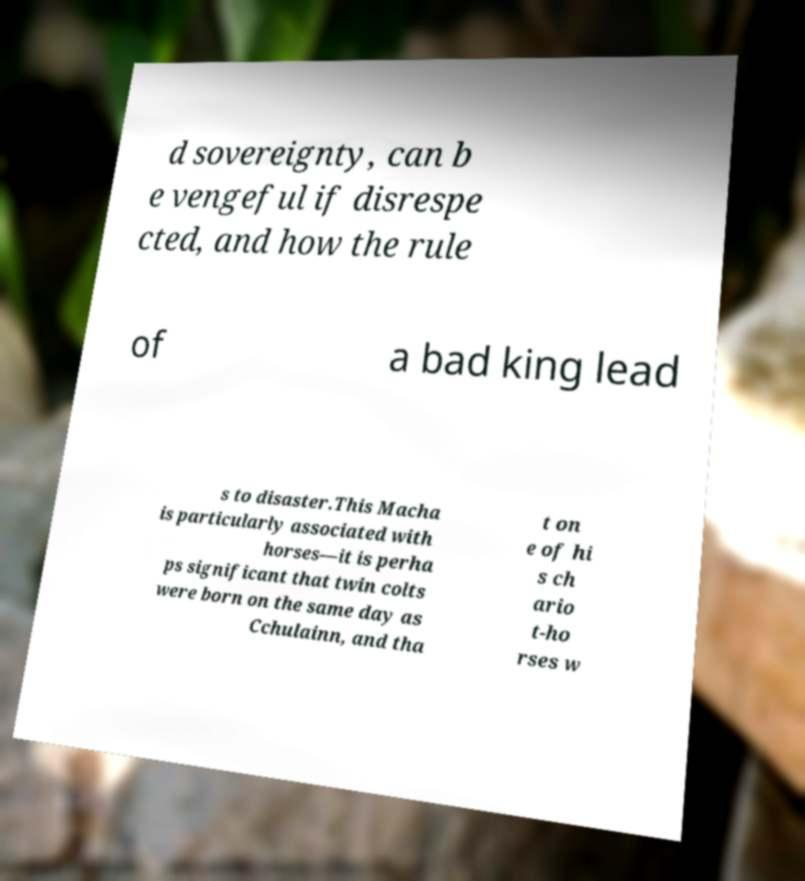I need the written content from this picture converted into text. Can you do that? d sovereignty, can b e vengeful if disrespe cted, and how the rule of a bad king lead s to disaster.This Macha is particularly associated with horses—it is perha ps significant that twin colts were born on the same day as Cchulainn, and tha t on e of hi s ch ario t-ho rses w 